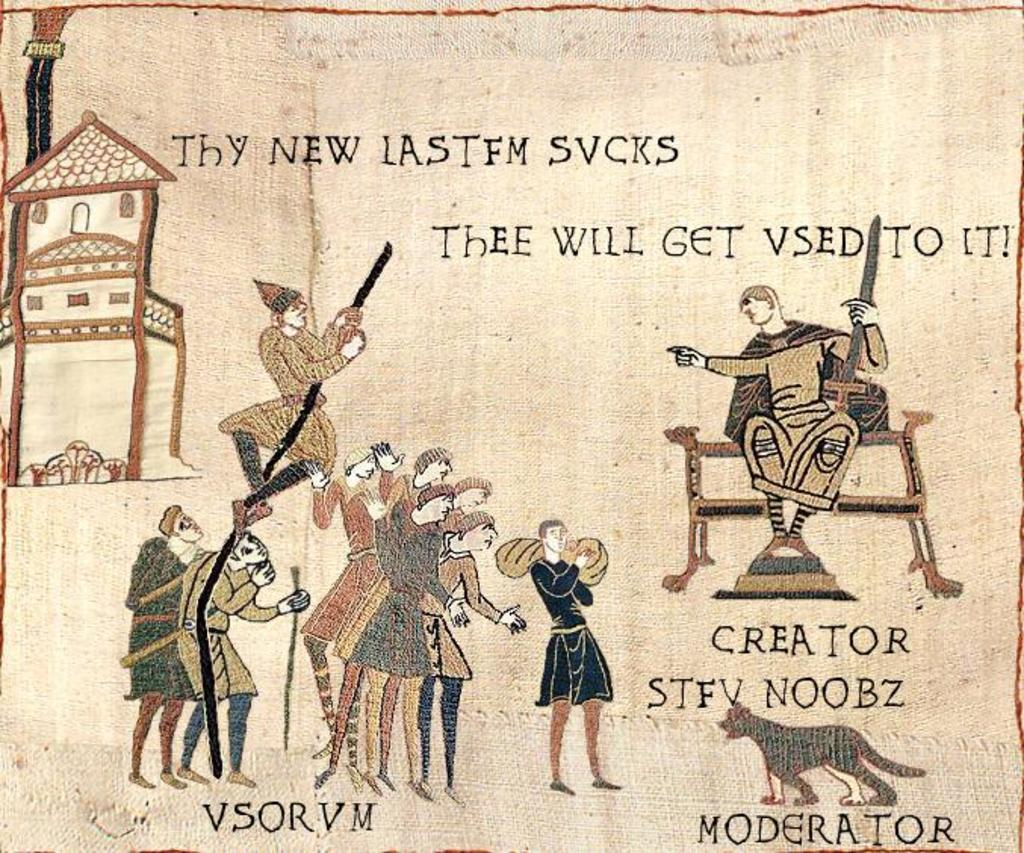Who or what can be seen in the image? There are people and an animal in the image. What type of structure is located on the left side of the image? There is a house on the left side of the image. Is there any text present in the image? Yes, there is text written on the image. What color is the gold in the middle of the bedroom in the image? There is no gold or bedroom present in the image. 